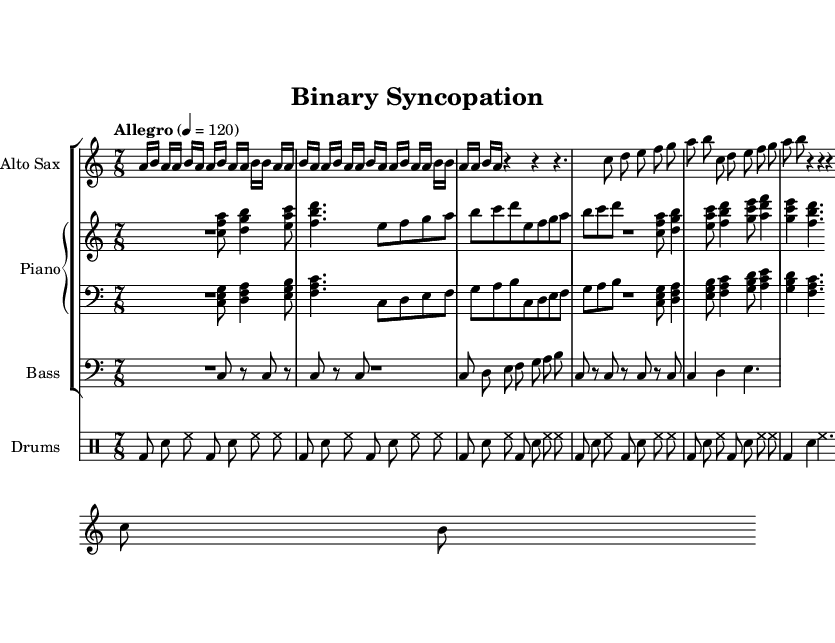What is the time signature of this music? The time signature is 7/8, which is indicated at the beginning of the score. The "7" shows there are seven beats in a measure, and the "8" indicates the eighth note gets the beat.
Answer: 7/8 What is the tempo marking of this piece? The tempo marking is "Allegro," with a specific tempo indication of 120 beats per minute. This is found in the global section at the beginning of the score.
Answer: Allegro 4 = 120 How many sections are there in the composition? The composition consists of five sections: Intro, A, B, C, and A' followed by an Outro. This can be determined by looking at the structure notated in the score.
Answer: Five Which instrument plays the highest pitch in this score? The Alto Sax, as indicated by the use of a treble clef and the relative pitches of the notes written in the top staff.
Answer: Alto Sax What type of musical pattern is used in the B section? The B section features a repeating melodic pattern that sequences through the notes of C, D, E, F, G, A, and B, as seen in the two repeated measures in that section.
Answer: Repeating melodic pattern How does the bass line in the A section primarily move? The bass line in the A section primarily moves in a pattern of alternating rests and repeating pitches, demonstrating a simple rhythmic structure with narrow melodic motion, as observed in the plotted notes for that section.
Answer: Alternating rests and repeating pitches 